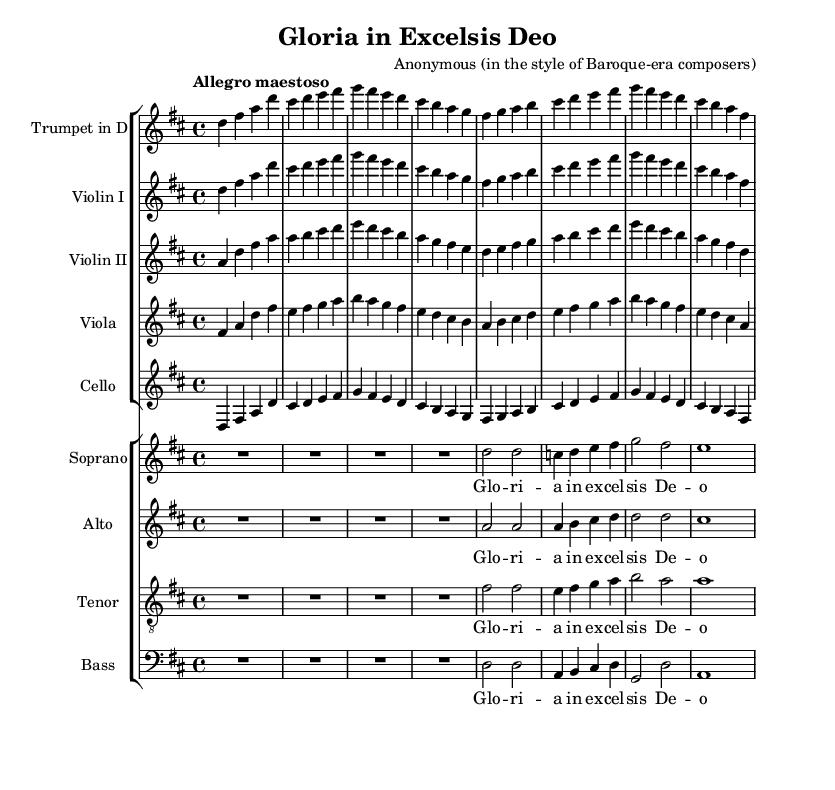What is the key signature of this music? The key signature is indicated at the beginning of the staff. Here, there are two sharps, which represent F sharp and C sharp, confirming that the music is in D major.
Answer: D major What is the time signature of the piece? The time signature is shown at the beginning of the score and is indicated as 4/4, meaning there are four beats in a measure and a quarter note gets one beat.
Answer: 4/4 What is the tempo marking for this piece? The tempo marking is located above the staff, reading "Allegro maestoso," indicating a fast and majestic tempo.
Answer: Allegro maestoso How many vocal parts are featured in the choir? By examining the choir staff section, we can count four distinct vocal parts: Soprano, Alto, Tenor, and Bass, making a total of four.
Answer: Four Which instruments are included in the orchestration? The orchestration is composed of a Trumpet in D, two Violins, a Viola, and a Cello, all visible in the staff group towards the top of the sheet music.
Answer: Trumpet in D, Violin I, Violin II, Viola, Cello What is the lyrical theme expressed in the choir? The lyrics provided in the score read "Gloria in excelsis Deo," which translates to "Glory to God in the highest," a common theme in sacred music.
Answer: Glory in excelsis Deo Which voice part has the melody from the beginning? Observing the soprano voice line on the sheet music reveals that it begins singing the main melody after the rest, indicating its prominence in the choral arrangement.
Answer: Soprano 